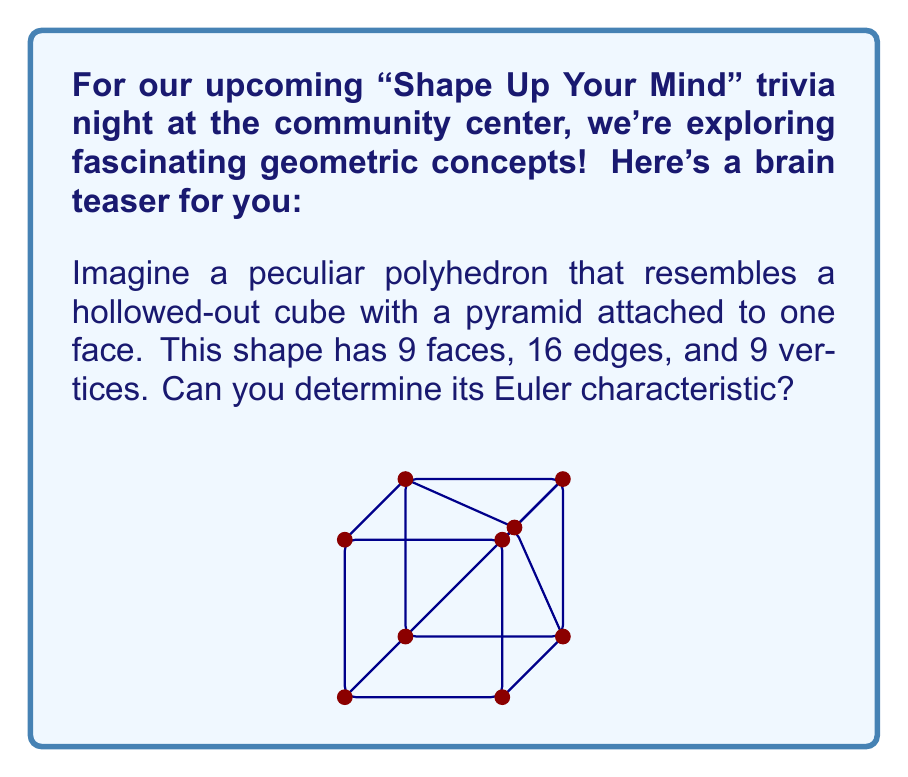Can you answer this question? To solve this problem, we'll use the Euler characteristic formula for polyhedra:

$$\chi = V - E + F$$

Where:
$\chi$ is the Euler characteristic
$V$ is the number of vertices
$E$ is the number of edges
$F$ is the number of faces

We are given:
$V = 9$ (vertices)
$E = 16$ (edges)
$F = 9$ (faces)

Let's substitute these values into the formula:

$$\chi = V - E + F$$
$$\chi = 9 - 16 + 9$$
$$\chi = 2$$

The calculation shows that the Euler characteristic of this polyhedron is 2.

It's worth noting that the Euler characteristic of 2 is consistent with the fact that this shape is topologically equivalent to a sphere. The hollowed-out cube with an attached pyramid can be continuously deformed into a sphere without changing its topological properties.
Answer: $\chi = 2$ 